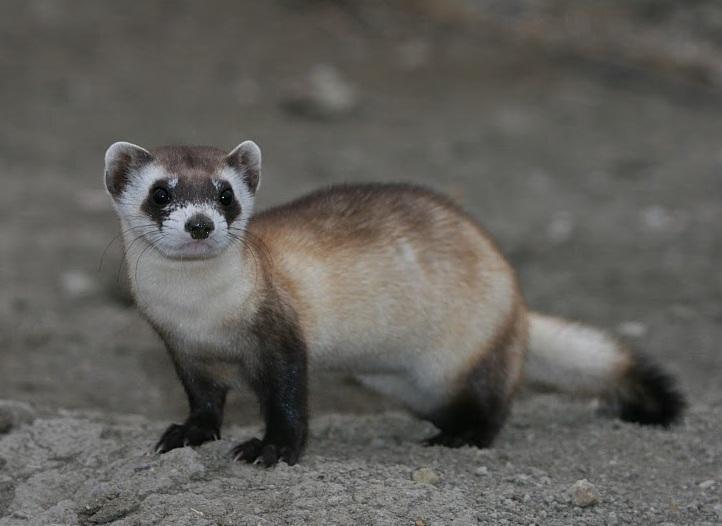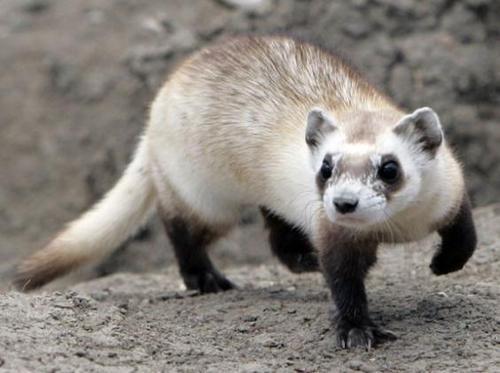The first image is the image on the left, the second image is the image on the right. Considering the images on both sides, is "Each image contains one ferret standing on dirt ground, with at least one front and one back paw on the ground." valid? Answer yes or no. Yes. The first image is the image on the left, the second image is the image on the right. Assess this claim about the two images: "Both animals are standing on all fours on the ground.". Correct or not? Answer yes or no. Yes. 